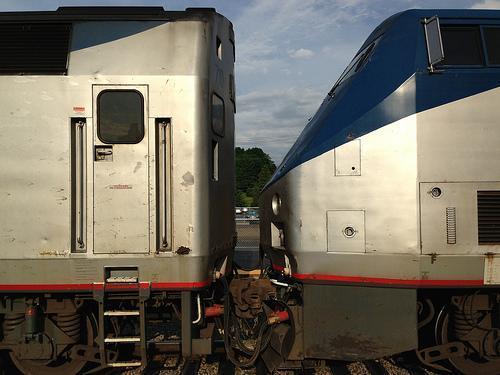How many train cars are in the photo?
Give a very brief answer. 2. 